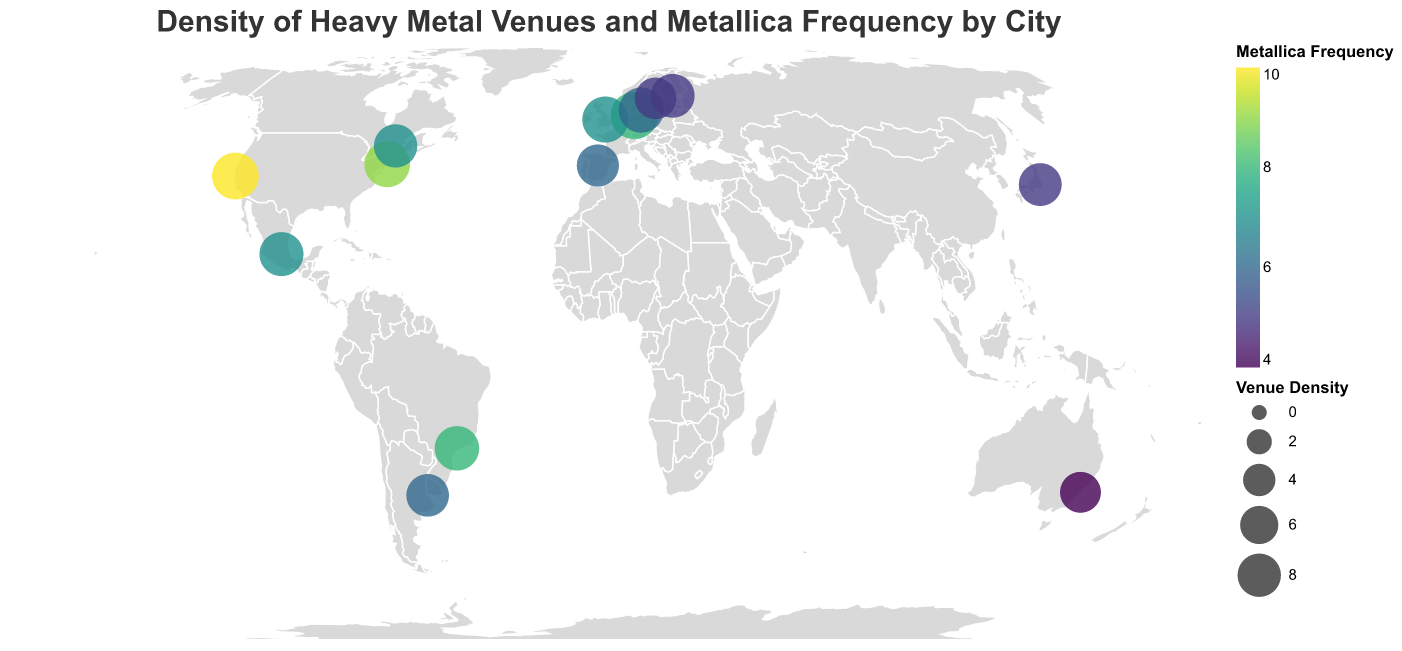What's the title of the figure? The title is located at the top center of the figure and is "Density of Heavy Metal Venues and Metallica Frequency by City".
Answer: Density of Heavy Metal Venues and Metallica Frequency by City How many cities in North America are displayed in the figure? The cities in North America are San Francisco, New York City, Montreal, and Mexico City, which totals to 4.
Answer: 4 Which city has the highest Density Score and Metallica Frequency? By referring to the size of the circles (Density Score) and the color intensity (Metallica Frequency), San Francisco has the highest scores with Density Score of 9.5 and Metallica Frequency of 10.
Answer: San Francisco What is the average Density Score of European cities? The Density Scores of European cities are 9.8, 9.2, 8.8, 7.5, 8.2, and 7.3. The sum is 50.8. There are 6 cities, so 50.8/6 = 8.47.
Answer: 8.47 How does the Metallica Frequency vary between Wacken and Stockholm? Wacken has a Metallica Frequency of 8 while Stockholm has a Metallica Frequency of 5. The difference is 8 - 5 = 3.
Answer: 3 Which city in South America has a higher Metallica Frequency, São Paulo or Buenos Aires? São Paulo has a Metallica Frequency of 8 compared to Buenos Aires which has a Metallica Frequency of 6. Therefore, São Paulo has a higher frequency.
Answer: São Paulo Identify the city with the lowest Density Score and Metallica Frequency. By looking at the smallest and least colored circle, Sydney has the lowest Density Score of 7.0 and Metallica Frequency of 4.
Answer: Sydney Which continent has the most cities listed in the figure? Europe has the most cities listed: Wacken, Donington, Roskilde, Madrid, Helsinki, and Stockholm, totaling 6 cities.
Answer: Europe What's the Density Score range for the North American cities on the plot? North American cities have the following Density Scores: 9.5, 9.0, 8.0, and 8.3. The range is from 8.0 to 9.5.
Answer: 8.0 to 9.5 Compare the Density Score of Tokyo to that of Helsinki. Tokyo has a Density Score of 7.8 while Helsinki has a Density Score of 8.2. The difference is 8.2 - 7.8 = 0.4.
Answer: 0.4 